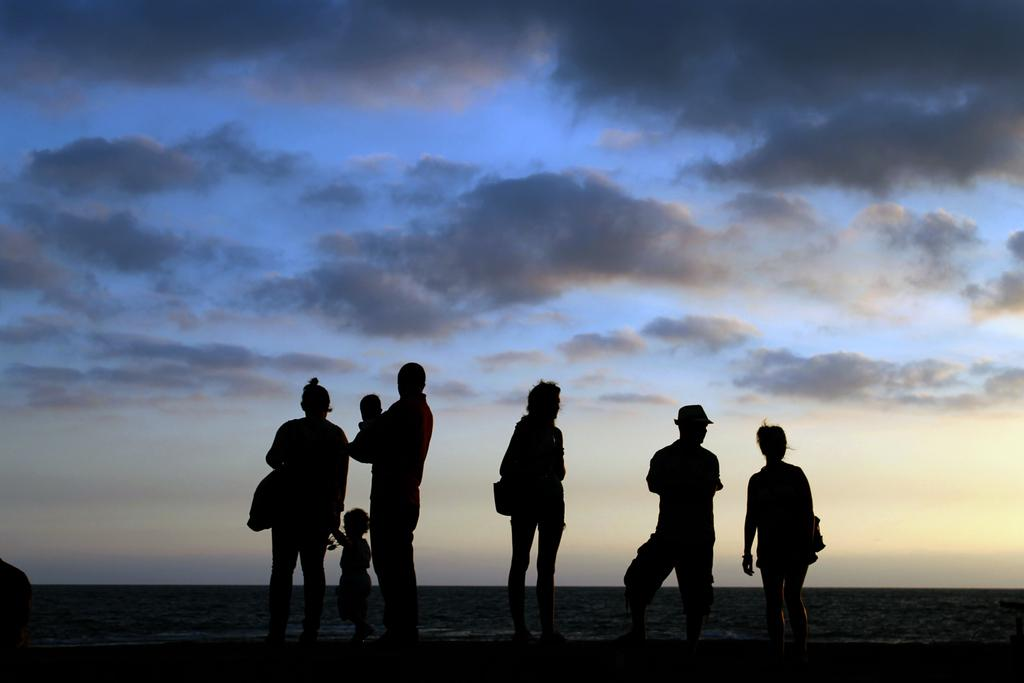What is the main subject of the image? The main subject of the image is a group of people. Where are the people located in the image? The group of people is in the middle of the image. What can be seen in the background of the image? There are clouds visible in the background of the image. What type of sheet is being used by the people in the image? There is no sheet present in the image; it only features a group of people and clouds in the background. 